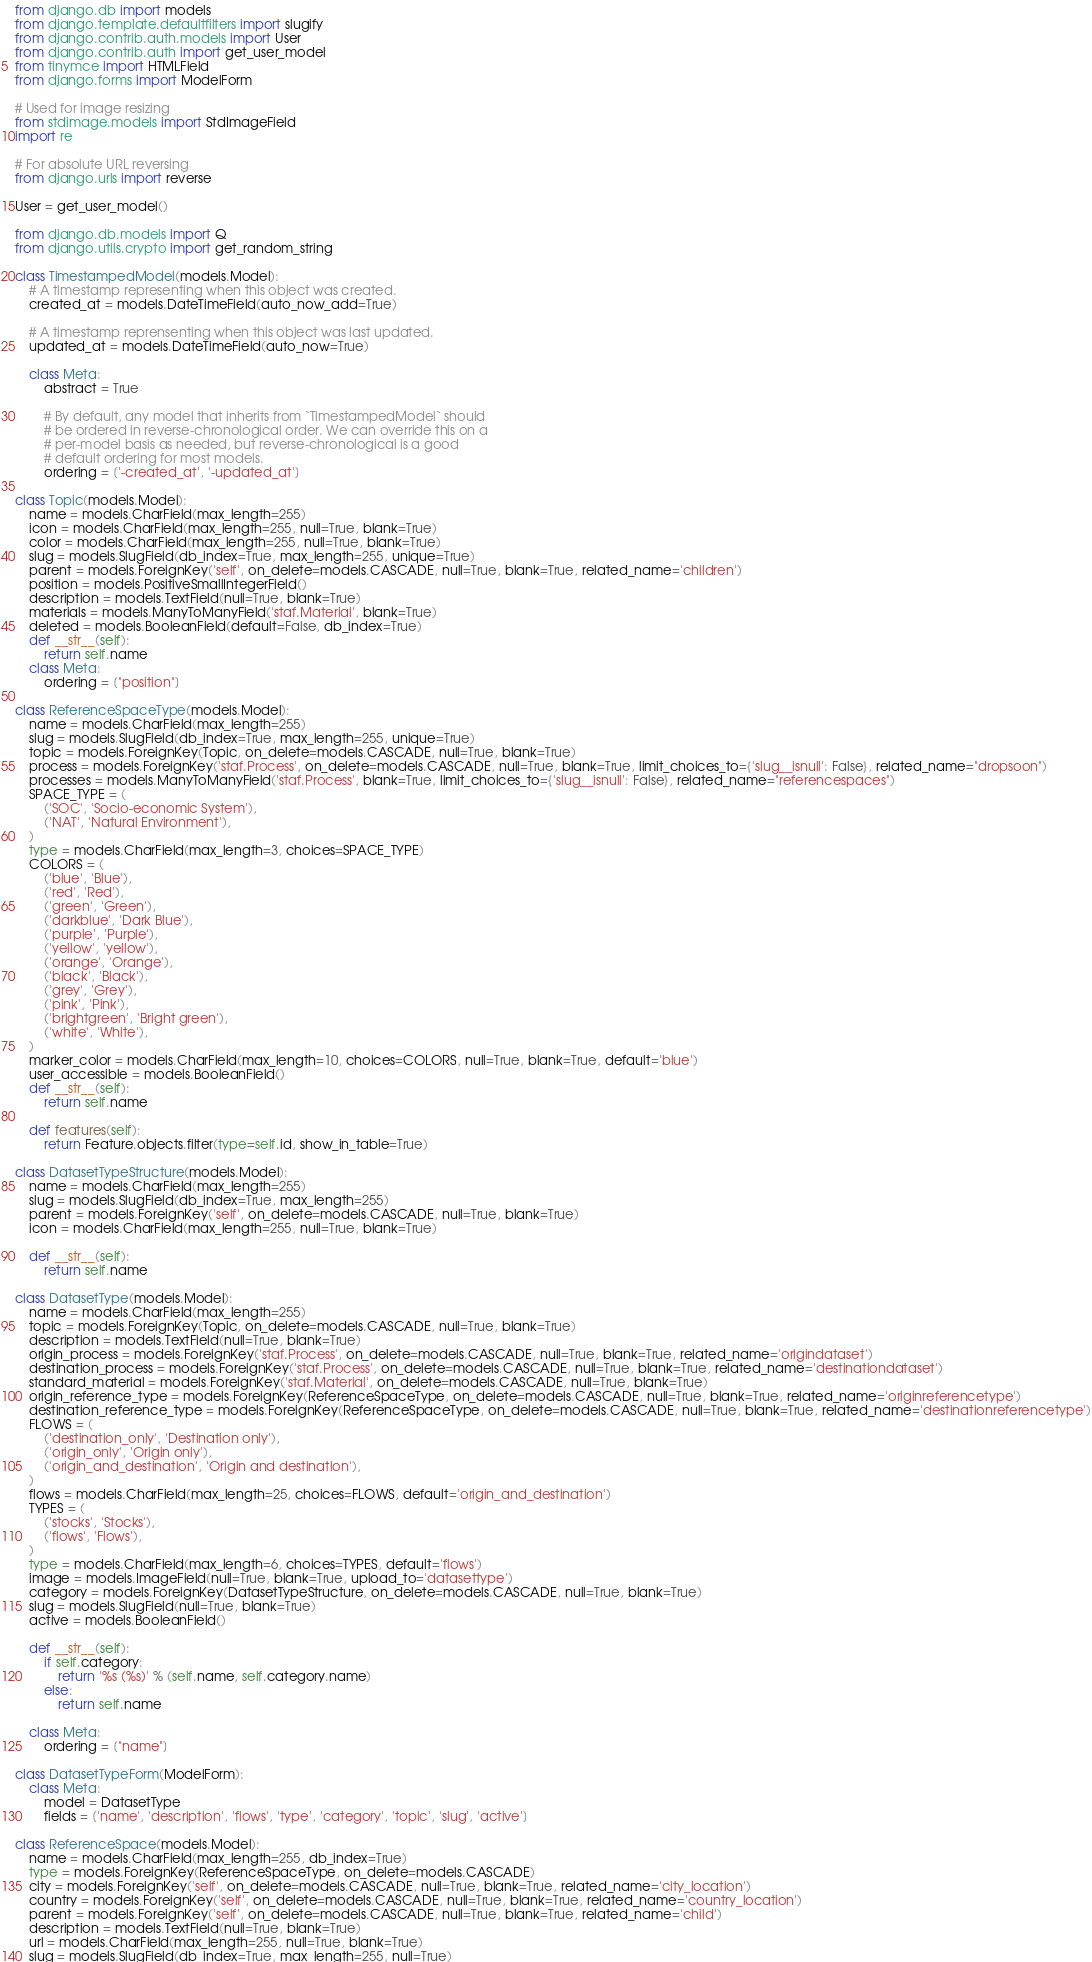<code> <loc_0><loc_0><loc_500><loc_500><_Python_>from django.db import models
from django.template.defaultfilters import slugify
from django.contrib.auth.models import User
from django.contrib.auth import get_user_model
from tinymce import HTMLField
from django.forms import ModelForm

# Used for image resizing
from stdimage.models import StdImageField
import re

# For absolute URL reversing
from django.urls import reverse

User = get_user_model()

from django.db.models import Q
from django.utils.crypto import get_random_string

class TimestampedModel(models.Model):
    # A timestamp representing when this object was created.
    created_at = models.DateTimeField(auto_now_add=True)

    # A timestamp reprensenting when this object was last updated.
    updated_at = models.DateTimeField(auto_now=True)

    class Meta:
        abstract = True

        # By default, any model that inherits from `TimestampedModel` should
        # be ordered in reverse-chronological order. We can override this on a
        # per-model basis as needed, but reverse-chronological is a good
        # default ordering for most models.
        ordering = ['-created_at', '-updated_at']

class Topic(models.Model):
    name = models.CharField(max_length=255)
    icon = models.CharField(max_length=255, null=True, blank=True)
    color = models.CharField(max_length=255, null=True, blank=True)
    slug = models.SlugField(db_index=True, max_length=255, unique=True)
    parent = models.ForeignKey('self', on_delete=models.CASCADE, null=True, blank=True, related_name='children')
    position = models.PositiveSmallIntegerField()
    description = models.TextField(null=True, blank=True)
    materials = models.ManyToManyField('staf.Material', blank=True)
    deleted = models.BooleanField(default=False, db_index=True)
    def __str__(self):
        return self.name
    class Meta:
        ordering = ["position"]

class ReferenceSpaceType(models.Model):
    name = models.CharField(max_length=255)
    slug = models.SlugField(db_index=True, max_length=255, unique=True)
    topic = models.ForeignKey(Topic, on_delete=models.CASCADE, null=True, blank=True)
    process = models.ForeignKey('staf.Process', on_delete=models.CASCADE, null=True, blank=True, limit_choices_to={'slug__isnull': False}, related_name="dropsoon")
    processes = models.ManyToManyField('staf.Process', blank=True, limit_choices_to={'slug__isnull': False}, related_name="referencespaces")
    SPACE_TYPE = (
        ('SOC', 'Socio-economic System'),
        ('NAT', 'Natural Environment'),
    )
    type = models.CharField(max_length=3, choices=SPACE_TYPE)
    COLORS = (
        ('blue', 'Blue'),
        ('red', 'Red'),
        ('green', 'Green'),
        ('darkblue', 'Dark Blue'),
        ('purple', 'Purple'),
        ('yellow', 'yellow'),
        ('orange', 'Orange'),
        ('black', 'Black'),
        ('grey', 'Grey'),
        ('pink', 'Pink'),
        ('brightgreen', 'Bright green'),
        ('white', 'White'),
    )
    marker_color = models.CharField(max_length=10, choices=COLORS, null=True, blank=True, default='blue')
    user_accessible = models.BooleanField()
    def __str__(self):
        return self.name

    def features(self):
        return Feature.objects.filter(type=self.id, show_in_table=True)

class DatasetTypeStructure(models.Model):
    name = models.CharField(max_length=255)
    slug = models.SlugField(db_index=True, max_length=255)
    parent = models.ForeignKey('self', on_delete=models.CASCADE, null=True, blank=True)
    icon = models.CharField(max_length=255, null=True, blank=True)

    def __str__(self):
        return self.name

class DatasetType(models.Model):
    name = models.CharField(max_length=255)
    topic = models.ForeignKey(Topic, on_delete=models.CASCADE, null=True, blank=True)
    description = models.TextField(null=True, blank=True)
    origin_process = models.ForeignKey('staf.Process', on_delete=models.CASCADE, null=True, blank=True, related_name='origindataset')
    destination_process = models.ForeignKey('staf.Process', on_delete=models.CASCADE, null=True, blank=True, related_name='destinationdataset')
    standard_material = models.ForeignKey('staf.Material', on_delete=models.CASCADE, null=True, blank=True)
    origin_reference_type = models.ForeignKey(ReferenceSpaceType, on_delete=models.CASCADE, null=True, blank=True, related_name='originreferencetype')
    destination_reference_type = models.ForeignKey(ReferenceSpaceType, on_delete=models.CASCADE, null=True, blank=True, related_name='destinationreferencetype')
    FLOWS = (
        ('destination_only', 'Destination only'),
        ('origin_only', 'Origin only'),
        ('origin_and_destination', 'Origin and destination'),
    )
    flows = models.CharField(max_length=25, choices=FLOWS, default='origin_and_destination')
    TYPES = (
        ('stocks', 'Stocks'),
        ('flows', 'Flows'),
    )
    type = models.CharField(max_length=6, choices=TYPES, default='flows')
    image = models.ImageField(null=True, blank=True, upload_to='datasettype')
    category = models.ForeignKey(DatasetTypeStructure, on_delete=models.CASCADE, null=True, blank=True)
    slug = models.SlugField(null=True, blank=True)
    active = models.BooleanField()

    def __str__(self):
        if self.category:
            return '%s (%s)' % (self.name, self.category.name)
        else:
            return self.name

    class Meta:
        ordering = ["name"]

class DatasetTypeForm(ModelForm):
    class Meta:
        model = DatasetType
        fields = ['name', 'description', 'flows', 'type', 'category', 'topic', 'slug', 'active']

class ReferenceSpace(models.Model):
    name = models.CharField(max_length=255, db_index=True)
    type = models.ForeignKey(ReferenceSpaceType, on_delete=models.CASCADE)
    city = models.ForeignKey('self', on_delete=models.CASCADE, null=True, blank=True, related_name='city_location')
    country = models.ForeignKey('self', on_delete=models.CASCADE, null=True, blank=True, related_name='country_location')
    parent = models.ForeignKey('self', on_delete=models.CASCADE, null=True, blank=True, related_name='child')
    description = models.TextField(null=True, blank=True)
    url = models.CharField(max_length=255, null=True, blank=True)
    slug = models.SlugField(db_index=True, max_length=255, null=True)</code> 